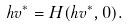Convert formula to latex. <formula><loc_0><loc_0><loc_500><loc_500>h v ^ { \ast } = H ( h v ^ { \ast } , 0 ) .</formula> 